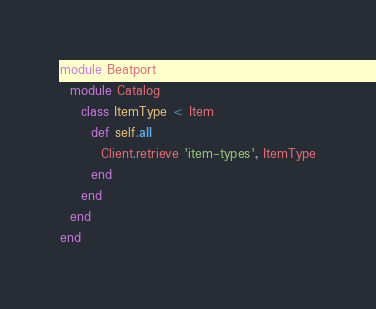Convert code to text. <code><loc_0><loc_0><loc_500><loc_500><_Ruby_>module Beatport
  module Catalog
    class ItemType < Item
      def self.all
        Client.retrieve 'item-types', ItemType
      end      
    end
  end
end</code> 